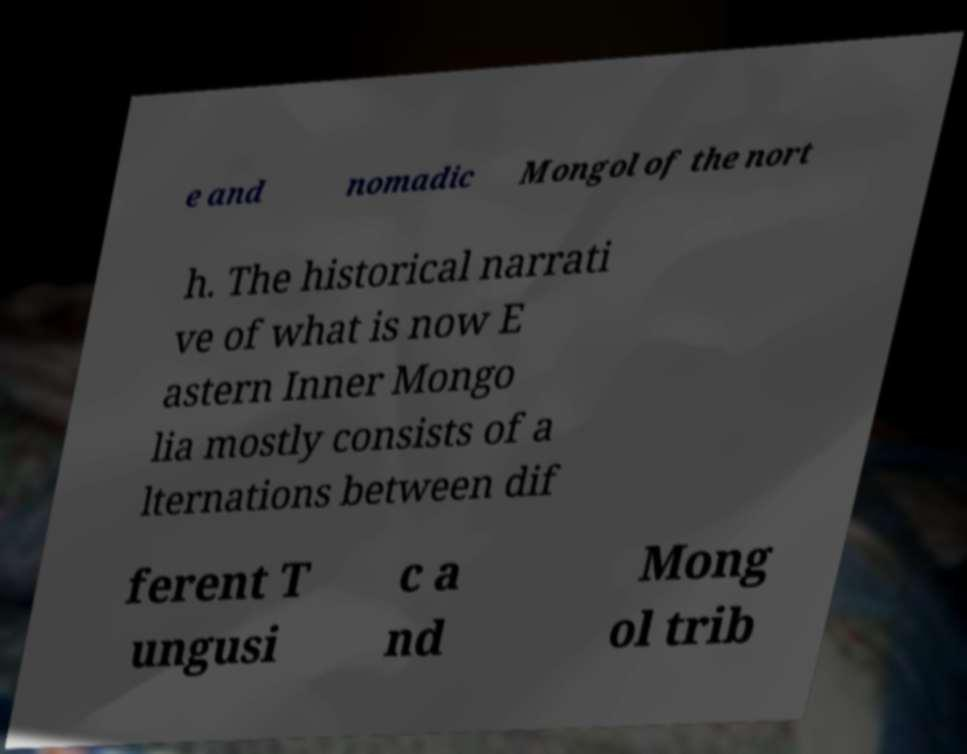Could you assist in decoding the text presented in this image and type it out clearly? e and nomadic Mongol of the nort h. The historical narrati ve of what is now E astern Inner Mongo lia mostly consists of a lternations between dif ferent T ungusi c a nd Mong ol trib 